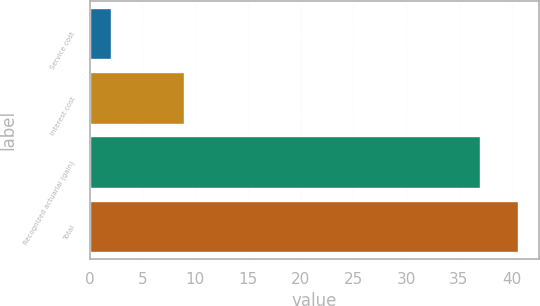Convert chart. <chart><loc_0><loc_0><loc_500><loc_500><bar_chart><fcel>Service cost<fcel>Interest cost<fcel>Recognized actuarial (gain)<fcel>Total<nl><fcel>2<fcel>9<fcel>37<fcel>40.6<nl></chart> 